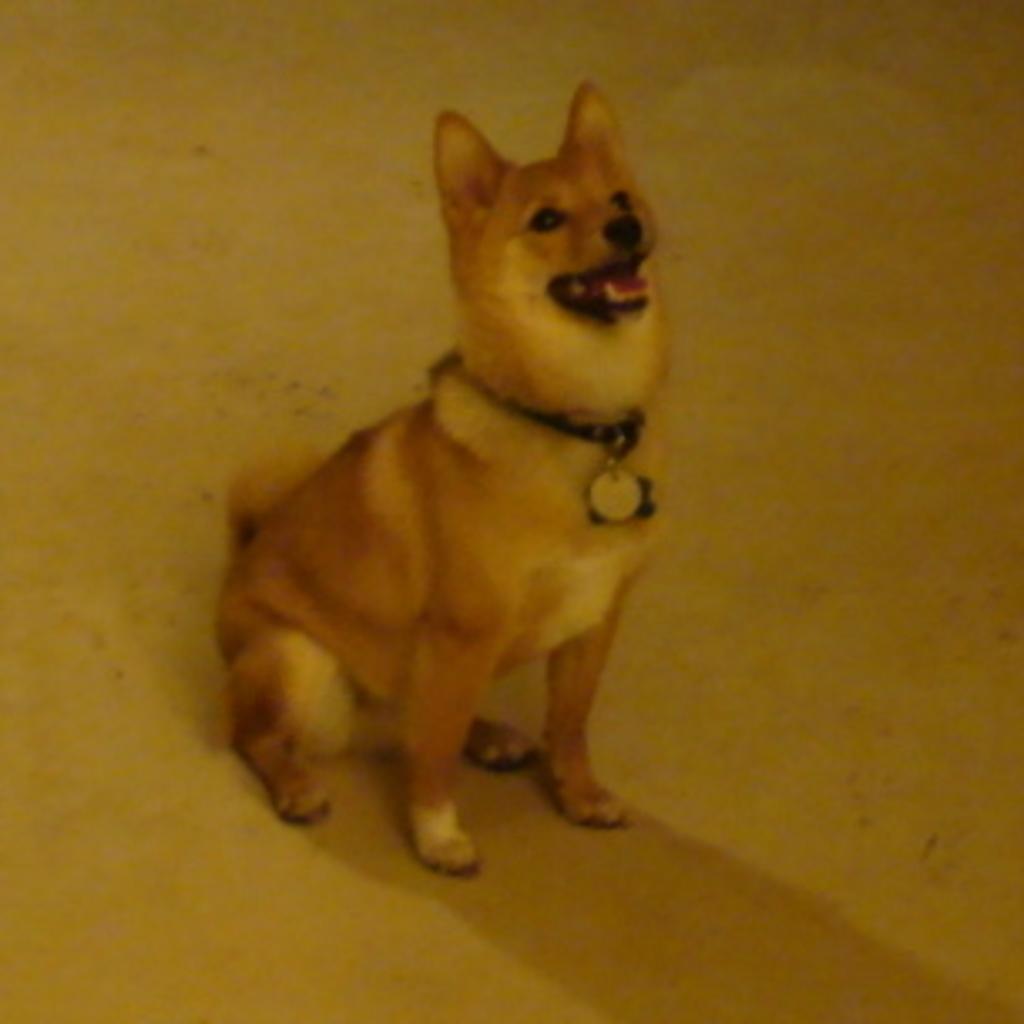Describe this image in one or two sentences. In this image there is a dog sitting on floor. Dog is tied with a belt having a locket to it. 